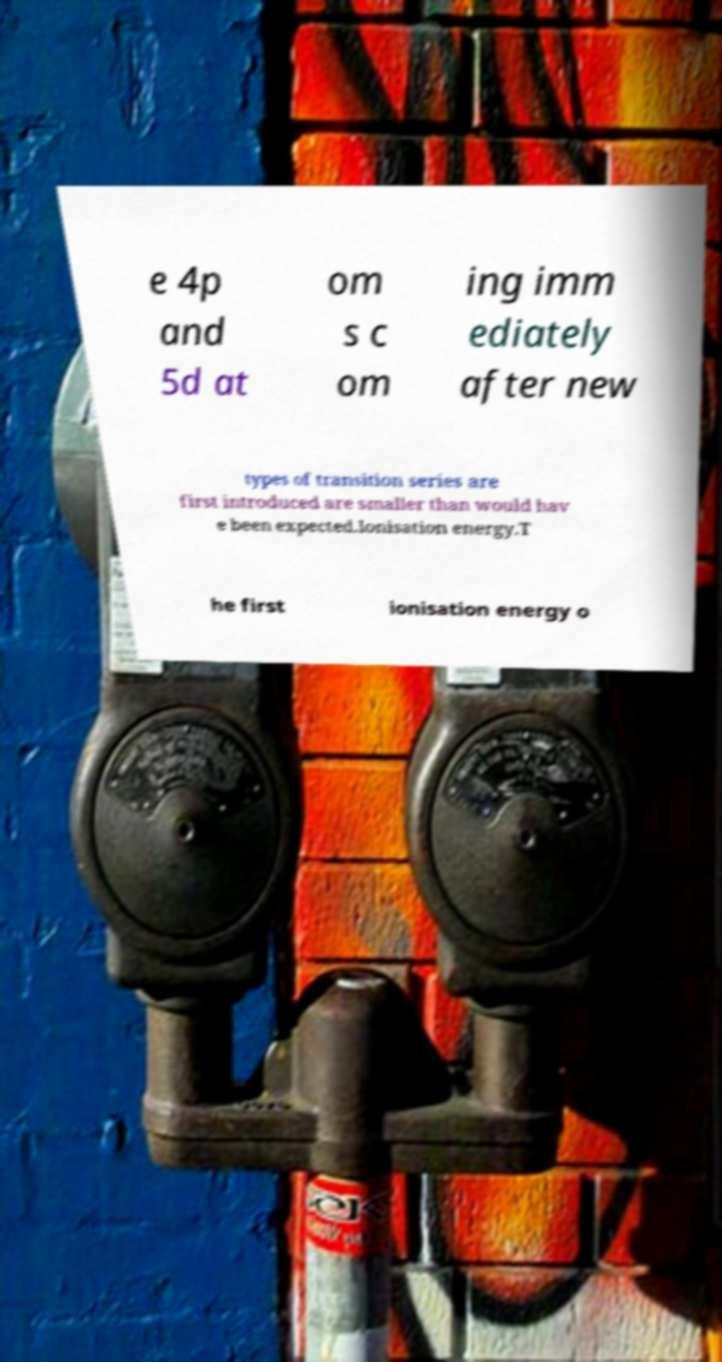Can you read and provide the text displayed in the image?This photo seems to have some interesting text. Can you extract and type it out for me? e 4p and 5d at om s c om ing imm ediately after new types of transition series are first introduced are smaller than would hav e been expected.Ionisation energy.T he first ionisation energy o 